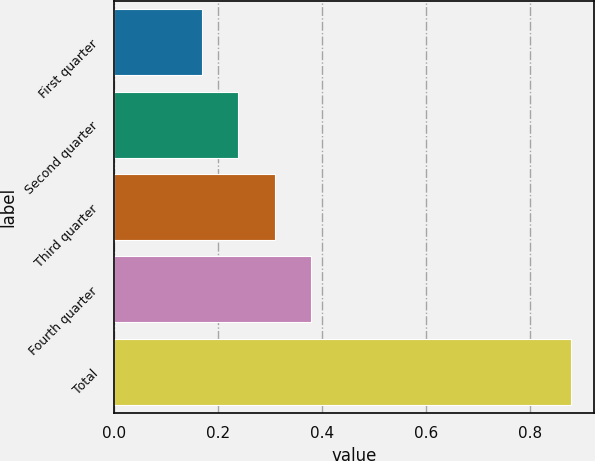<chart> <loc_0><loc_0><loc_500><loc_500><bar_chart><fcel>First quarter<fcel>Second quarter<fcel>Third quarter<fcel>Fourth quarter<fcel>Total<nl><fcel>0.17<fcel>0.24<fcel>0.31<fcel>0.38<fcel>0.88<nl></chart> 